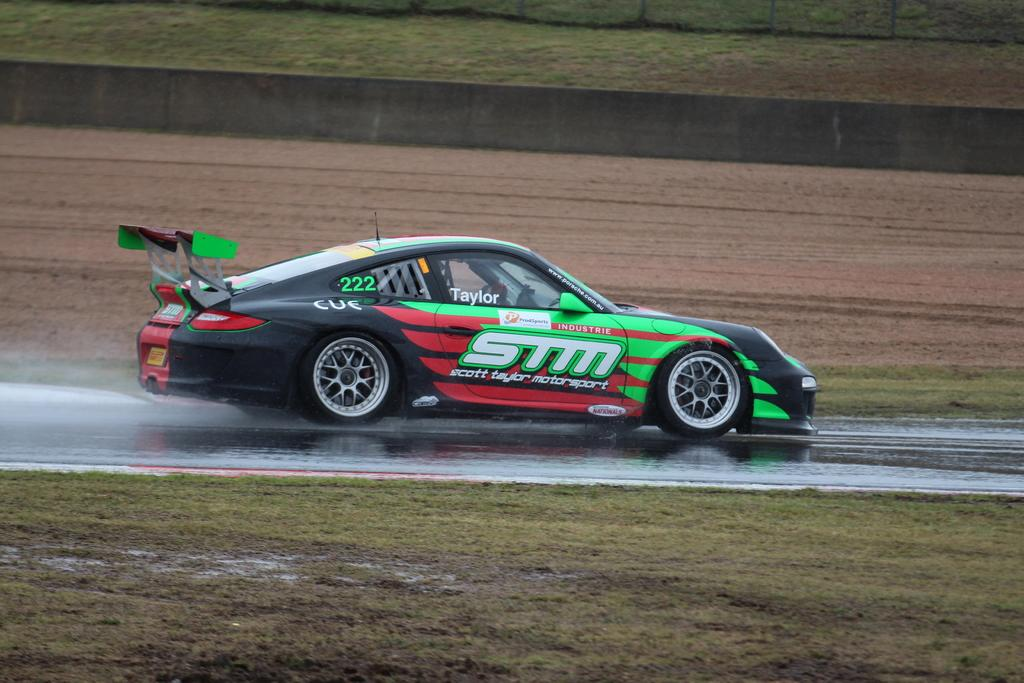What is the main subject of the image? A: The main subject of the image is a car. Where is the car located in the image? The car is on the road in the image. What colors can be seen on the car? The car has black, green, and red colors. What can be seen in the background of the image? There is a wall and open land in the background of the image. How does the car feel about the argument happening in the background? There is no argument happening in the background of the image, and cars do not have feelings. 